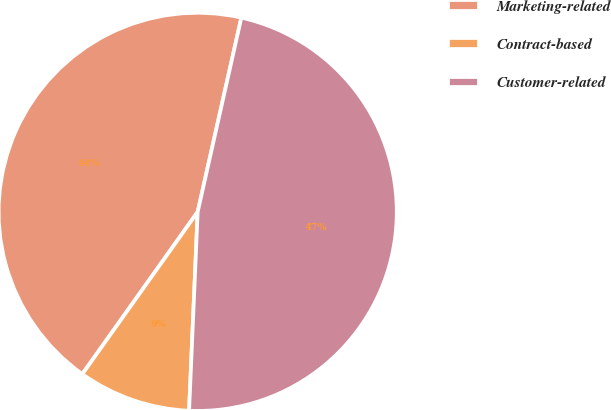Convert chart to OTSL. <chart><loc_0><loc_0><loc_500><loc_500><pie_chart><fcel>Marketing-related<fcel>Contract-based<fcel>Customer-related<nl><fcel>43.68%<fcel>9.15%<fcel>47.17%<nl></chart> 